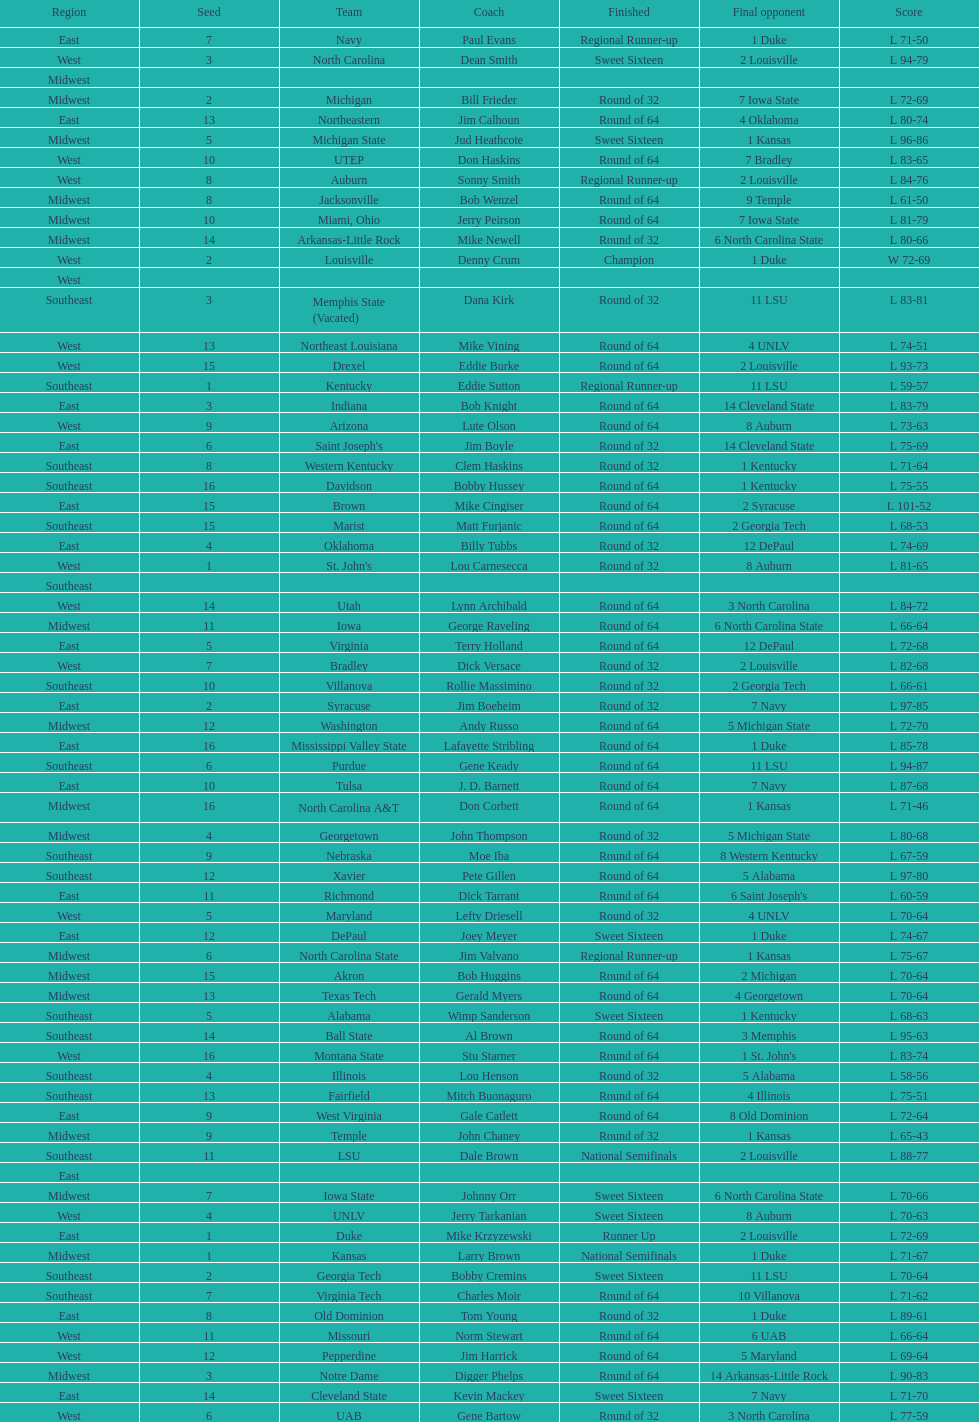Who was the only champion? Louisville. 